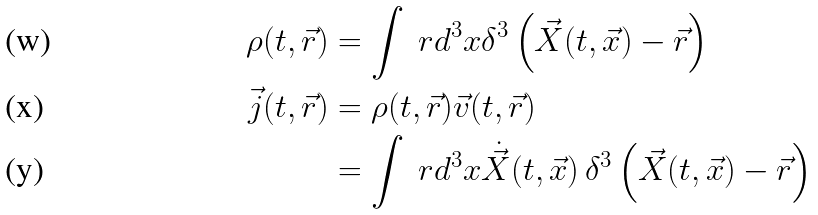<formula> <loc_0><loc_0><loc_500><loc_500>\rho ( t , \vec { r } ) & = \int \ r d { ^ { 3 } x } \delta ^ { 3 } \left ( \vec { X } ( t , \vec { x } ) - \vec { r } \right ) \\ \vec { j } ( t , \vec { r } ) & = \rho ( t , \vec { r } ) \vec { v } ( t , \vec { r } ) \\ & = \int \ r d { ^ { 3 } x } \dot { \vec { X } } ( t , \vec { x } ) \, \delta ^ { 3 } \left ( \vec { X } ( t , \vec { x } ) - \vec { r } \right )</formula> 